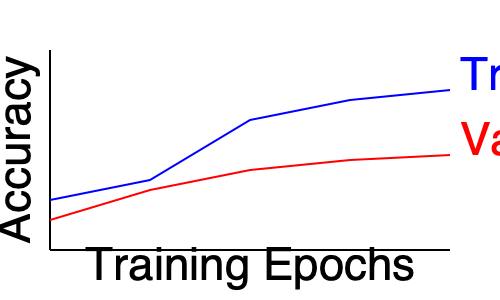As an expert in AI research evaluation, analyze the given machine learning performance chart. What potential issue does this graph indicate, and what strategy would you recommend to address it? To analyze this chart and identify potential issues, let's follow these steps:

1. Interpret the graph:
   - The blue line represents training accuracy
   - The red line represents validation accuracy
   - The x-axis shows training epochs
   - The y-axis shows accuracy

2. Observe the trends:
   - Training accuracy is consistently increasing over epochs
   - Validation accuracy initially increases but then plateaus

3. Identify the issue:
   The gap between training and validation accuracy widens as training progresses. This pattern typically indicates overfitting, where the model performs well on training data but fails to generalize to unseen data.

4. Understand the implications:
   Overfitting can lead to poor model performance on new, unseen data, limiting the model's practical applicability in real-world scenarios.

5. Recommend a strategy:
   To address overfitting, we can employ regularization techniques. Some options include:
   - L1 or L2 regularization to constrain model weights
   - Dropout to reduce reliance on specific neurons
   - Early stopping to halt training before overfitting becomes severe
   - Data augmentation to increase the diversity of the training set

Given the academic context, a comprehensive approach would be to implement and compare multiple regularization techniques, analyzing their impact on model performance and generalization.
Answer: Overfitting; implement regularization techniques 